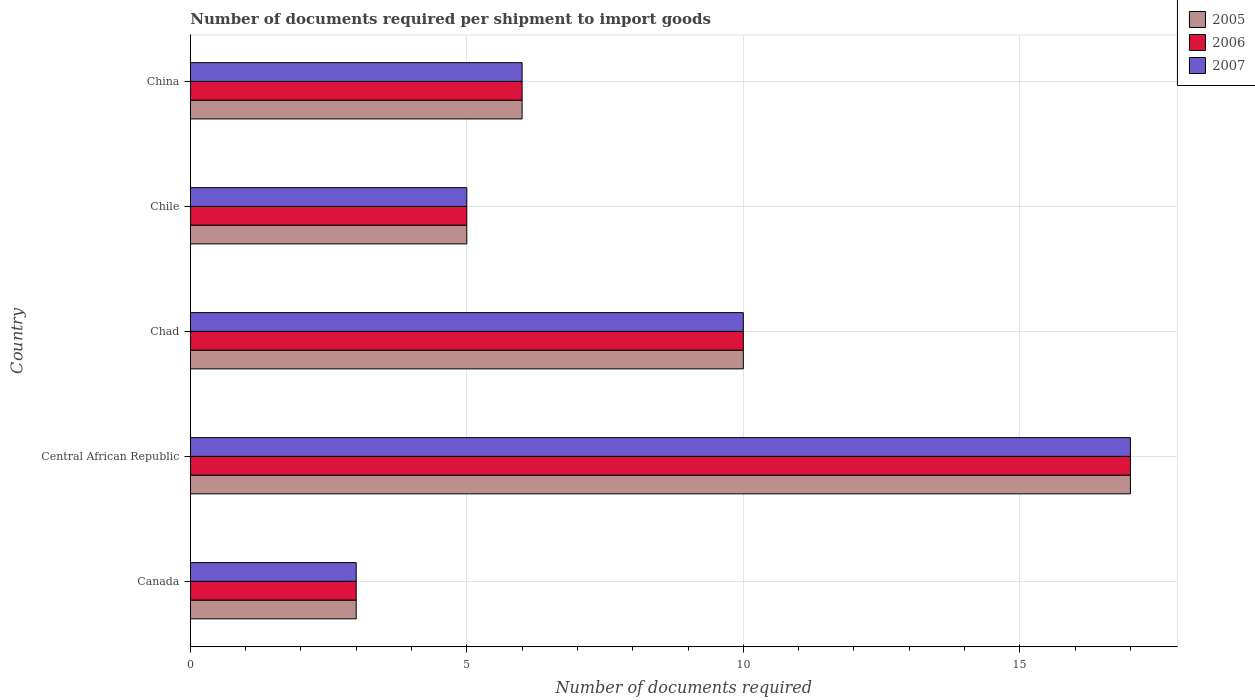How many groups of bars are there?
Your response must be concise. 5. Are the number of bars per tick equal to the number of legend labels?
Provide a succinct answer. Yes. What is the label of the 5th group of bars from the top?
Offer a very short reply. Canada. What is the number of documents required per shipment to import goods in 2005 in Chile?
Provide a short and direct response. 5. In which country was the number of documents required per shipment to import goods in 2007 maximum?
Ensure brevity in your answer.  Central African Republic. In which country was the number of documents required per shipment to import goods in 2005 minimum?
Give a very brief answer. Canada. What is the total number of documents required per shipment to import goods in 2007 in the graph?
Offer a very short reply. 41. In how many countries, is the number of documents required per shipment to import goods in 2005 greater than 2 ?
Give a very brief answer. 5. What is the ratio of the number of documents required per shipment to import goods in 2007 in Canada to that in Chile?
Offer a very short reply. 0.6. Is the number of documents required per shipment to import goods in 2006 in Canada less than that in Chile?
Your answer should be compact. Yes. Is the difference between the number of documents required per shipment to import goods in 2005 in Chad and China greater than the difference between the number of documents required per shipment to import goods in 2007 in Chad and China?
Provide a short and direct response. No. What does the 3rd bar from the bottom in China represents?
Provide a short and direct response. 2007. Is it the case that in every country, the sum of the number of documents required per shipment to import goods in 2007 and number of documents required per shipment to import goods in 2005 is greater than the number of documents required per shipment to import goods in 2006?
Provide a succinct answer. Yes. How many countries are there in the graph?
Ensure brevity in your answer.  5. How many legend labels are there?
Your response must be concise. 3. How are the legend labels stacked?
Provide a succinct answer. Vertical. What is the title of the graph?
Provide a succinct answer. Number of documents required per shipment to import goods. What is the label or title of the X-axis?
Ensure brevity in your answer.  Number of documents required. What is the Number of documents required of 2005 in Canada?
Your answer should be compact. 3. What is the Number of documents required in 2007 in Canada?
Give a very brief answer. 3. What is the Number of documents required of 2005 in Central African Republic?
Provide a succinct answer. 17. What is the Number of documents required of 2007 in Central African Republic?
Give a very brief answer. 17. What is the Number of documents required of 2006 in Chad?
Offer a very short reply. 10. What is the Number of documents required of 2005 in Chile?
Your answer should be compact. 5. Across all countries, what is the maximum Number of documents required of 2005?
Offer a very short reply. 17. Across all countries, what is the minimum Number of documents required of 2006?
Provide a succinct answer. 3. Across all countries, what is the minimum Number of documents required of 2007?
Your response must be concise. 3. What is the total Number of documents required in 2005 in the graph?
Offer a very short reply. 41. What is the total Number of documents required of 2007 in the graph?
Provide a succinct answer. 41. What is the difference between the Number of documents required in 2005 in Canada and that in Central African Republic?
Make the answer very short. -14. What is the difference between the Number of documents required in 2007 in Canada and that in Central African Republic?
Offer a terse response. -14. What is the difference between the Number of documents required in 2005 in Canada and that in Chad?
Make the answer very short. -7. What is the difference between the Number of documents required in 2006 in Canada and that in Chad?
Offer a terse response. -7. What is the difference between the Number of documents required in 2005 in Canada and that in Chile?
Offer a very short reply. -2. What is the difference between the Number of documents required in 2005 in Canada and that in China?
Your answer should be compact. -3. What is the difference between the Number of documents required of 2006 in Canada and that in China?
Your response must be concise. -3. What is the difference between the Number of documents required of 2006 in Central African Republic and that in Chile?
Make the answer very short. 12. What is the difference between the Number of documents required in 2007 in Central African Republic and that in Chile?
Make the answer very short. 12. What is the difference between the Number of documents required in 2006 in Central African Republic and that in China?
Offer a very short reply. 11. What is the difference between the Number of documents required in 2007 in Central African Republic and that in China?
Your answer should be very brief. 11. What is the difference between the Number of documents required in 2006 in Chad and that in Chile?
Your answer should be very brief. 5. What is the difference between the Number of documents required of 2007 in Chad and that in Chile?
Provide a succinct answer. 5. What is the difference between the Number of documents required in 2005 in Canada and the Number of documents required in 2006 in Central African Republic?
Your response must be concise. -14. What is the difference between the Number of documents required in 2005 in Canada and the Number of documents required in 2007 in Central African Republic?
Your answer should be compact. -14. What is the difference between the Number of documents required of 2005 in Canada and the Number of documents required of 2006 in Chile?
Ensure brevity in your answer.  -2. What is the difference between the Number of documents required of 2005 in Canada and the Number of documents required of 2007 in Chile?
Provide a short and direct response. -2. What is the difference between the Number of documents required in 2006 in Canada and the Number of documents required in 2007 in China?
Make the answer very short. -3. What is the difference between the Number of documents required of 2005 in Central African Republic and the Number of documents required of 2006 in Chad?
Make the answer very short. 7. What is the difference between the Number of documents required of 2006 in Central African Republic and the Number of documents required of 2007 in Chad?
Your answer should be compact. 7. What is the difference between the Number of documents required in 2005 in Central African Republic and the Number of documents required in 2006 in Chile?
Your response must be concise. 12. What is the difference between the Number of documents required of 2006 in Central African Republic and the Number of documents required of 2007 in Chile?
Offer a terse response. 12. What is the difference between the Number of documents required in 2005 in Central African Republic and the Number of documents required in 2006 in China?
Provide a succinct answer. 11. What is the difference between the Number of documents required in 2005 in Central African Republic and the Number of documents required in 2007 in China?
Ensure brevity in your answer.  11. What is the difference between the Number of documents required of 2006 in Central African Republic and the Number of documents required of 2007 in China?
Provide a short and direct response. 11. What is the difference between the Number of documents required of 2005 in Chad and the Number of documents required of 2006 in Chile?
Provide a succinct answer. 5. What is the difference between the Number of documents required of 2005 in Chad and the Number of documents required of 2006 in China?
Offer a very short reply. 4. What is the difference between the Number of documents required of 2005 in Chad and the Number of documents required of 2007 in China?
Keep it short and to the point. 4. What is the difference between the Number of documents required in 2005 in Chile and the Number of documents required in 2006 in China?
Your answer should be compact. -1. What is the difference between the Number of documents required of 2005 in Chile and the Number of documents required of 2007 in China?
Give a very brief answer. -1. What is the average Number of documents required in 2006 per country?
Make the answer very short. 8.2. What is the difference between the Number of documents required in 2005 and Number of documents required in 2007 in Canada?
Make the answer very short. 0. What is the difference between the Number of documents required of 2005 and Number of documents required of 2006 in Central African Republic?
Your response must be concise. 0. What is the difference between the Number of documents required in 2005 and Number of documents required in 2006 in Chile?
Provide a succinct answer. 0. What is the difference between the Number of documents required in 2005 and Number of documents required in 2007 in Chile?
Your answer should be compact. 0. What is the difference between the Number of documents required in 2006 and Number of documents required in 2007 in Chile?
Ensure brevity in your answer.  0. What is the ratio of the Number of documents required of 2005 in Canada to that in Central African Republic?
Give a very brief answer. 0.18. What is the ratio of the Number of documents required of 2006 in Canada to that in Central African Republic?
Keep it short and to the point. 0.18. What is the ratio of the Number of documents required in 2007 in Canada to that in Central African Republic?
Make the answer very short. 0.18. What is the ratio of the Number of documents required of 2005 in Canada to that in Chad?
Your answer should be compact. 0.3. What is the ratio of the Number of documents required in 2006 in Canada to that in Chad?
Provide a short and direct response. 0.3. What is the ratio of the Number of documents required in 2007 in Canada to that in Chad?
Keep it short and to the point. 0.3. What is the ratio of the Number of documents required of 2007 in Canada to that in Chile?
Your answer should be compact. 0.6. What is the ratio of the Number of documents required in 2005 in Canada to that in China?
Provide a succinct answer. 0.5. What is the ratio of the Number of documents required of 2006 in Canada to that in China?
Ensure brevity in your answer.  0.5. What is the ratio of the Number of documents required of 2006 in Central African Republic to that in Chad?
Give a very brief answer. 1.7. What is the ratio of the Number of documents required in 2005 in Central African Republic to that in Chile?
Your answer should be very brief. 3.4. What is the ratio of the Number of documents required of 2006 in Central African Republic to that in Chile?
Keep it short and to the point. 3.4. What is the ratio of the Number of documents required of 2007 in Central African Republic to that in Chile?
Give a very brief answer. 3.4. What is the ratio of the Number of documents required in 2005 in Central African Republic to that in China?
Your response must be concise. 2.83. What is the ratio of the Number of documents required of 2006 in Central African Republic to that in China?
Offer a terse response. 2.83. What is the ratio of the Number of documents required of 2007 in Central African Republic to that in China?
Your answer should be very brief. 2.83. What is the ratio of the Number of documents required of 2005 in Chad to that in Chile?
Your response must be concise. 2. What is the ratio of the Number of documents required in 2006 in Chad to that in Chile?
Ensure brevity in your answer.  2. What is the ratio of the Number of documents required in 2007 in Chad to that in Chile?
Give a very brief answer. 2. What is the ratio of the Number of documents required of 2005 in Chad to that in China?
Keep it short and to the point. 1.67. What is the ratio of the Number of documents required of 2006 in Chad to that in China?
Your answer should be compact. 1.67. What is the ratio of the Number of documents required in 2007 in Chad to that in China?
Give a very brief answer. 1.67. What is the ratio of the Number of documents required of 2007 in Chile to that in China?
Keep it short and to the point. 0.83. What is the difference between the highest and the second highest Number of documents required of 2005?
Give a very brief answer. 7. What is the difference between the highest and the second highest Number of documents required in 2007?
Keep it short and to the point. 7. What is the difference between the highest and the lowest Number of documents required of 2006?
Provide a succinct answer. 14. What is the difference between the highest and the lowest Number of documents required of 2007?
Your response must be concise. 14. 